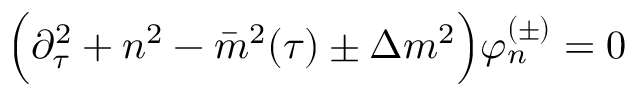<formula> <loc_0><loc_0><loc_500><loc_500>\left ( \partial _ { \tau } ^ { 2 } + n ^ { 2 } - \bar { m } ^ { 2 } ( \tau ) \pm \Delta m ^ { 2 } \right ) \varphi _ { n } ^ { ( \pm ) } = 0</formula> 